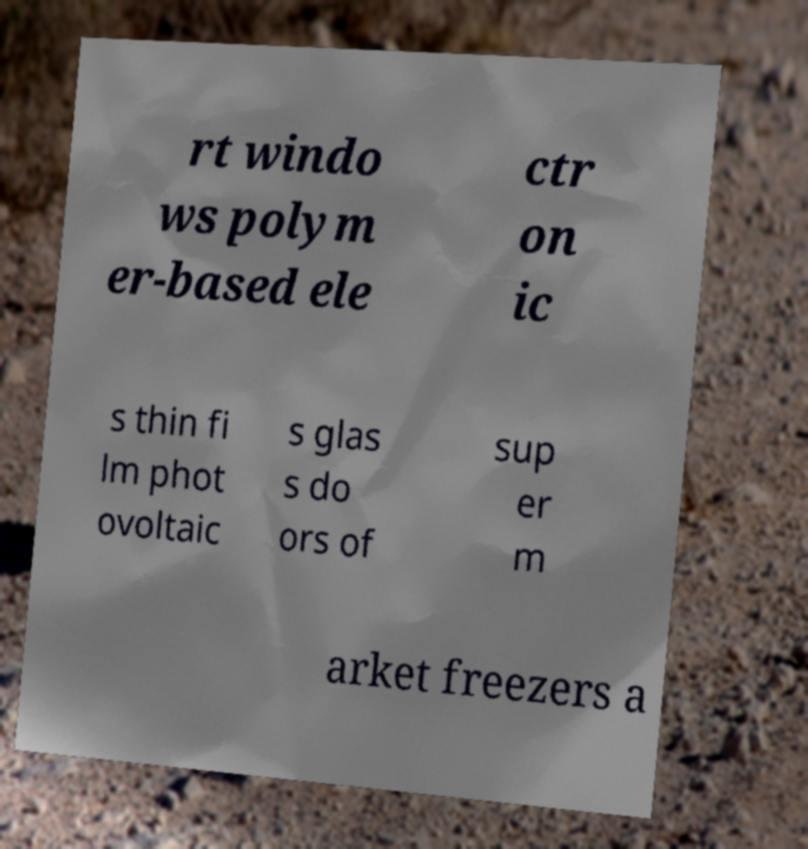There's text embedded in this image that I need extracted. Can you transcribe it verbatim? rt windo ws polym er-based ele ctr on ic s thin fi lm phot ovoltaic s glas s do ors of sup er m arket freezers a 